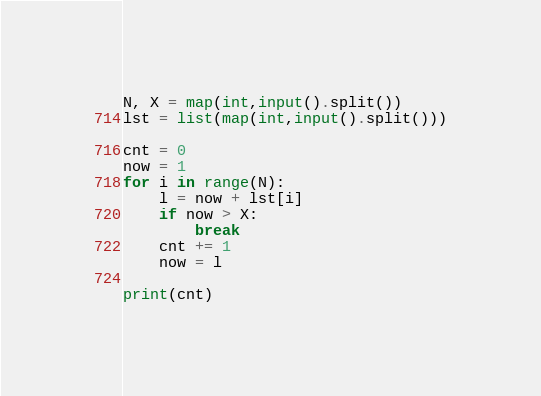Convert code to text. <code><loc_0><loc_0><loc_500><loc_500><_Python_>N, X = map(int,input().split())
lst = list(map(int,input().split()))

cnt = 0
now = 1
for i in range(N):
    l = now + lst[i]
    if now > X:
        break
    cnt += 1
    now = l

print(cnt)</code> 